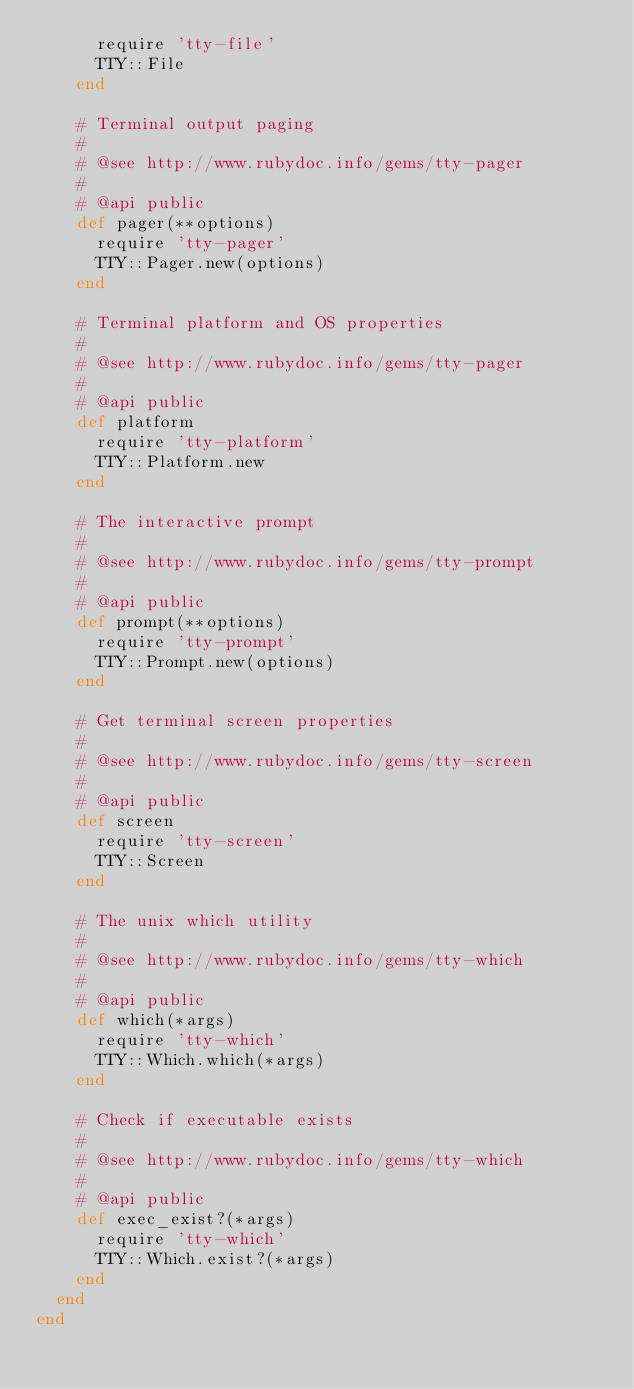Convert code to text. <code><loc_0><loc_0><loc_500><loc_500><_Ruby_>      require 'tty-file'
      TTY::File
    end

    # Terminal output paging
    #
    # @see http://www.rubydoc.info/gems/tty-pager
    #
    # @api public
    def pager(**options)
      require 'tty-pager'
      TTY::Pager.new(options)
    end

    # Terminal platform and OS properties
    #
    # @see http://www.rubydoc.info/gems/tty-pager
    #
    # @api public
    def platform
      require 'tty-platform'
      TTY::Platform.new
    end

    # The interactive prompt
    #
    # @see http://www.rubydoc.info/gems/tty-prompt
    #
    # @api public
    def prompt(**options)
      require 'tty-prompt'
      TTY::Prompt.new(options)
    end

    # Get terminal screen properties
    #
    # @see http://www.rubydoc.info/gems/tty-screen
    #
    # @api public
    def screen
      require 'tty-screen'
      TTY::Screen
    end

    # The unix which utility
    #
    # @see http://www.rubydoc.info/gems/tty-which
    #
    # @api public
    def which(*args)
      require 'tty-which'
      TTY::Which.which(*args)
    end

    # Check if executable exists
    #
    # @see http://www.rubydoc.info/gems/tty-which
    #
    # @api public
    def exec_exist?(*args)
      require 'tty-which'
      TTY::Which.exist?(*args)
    end
  end
end
</code> 